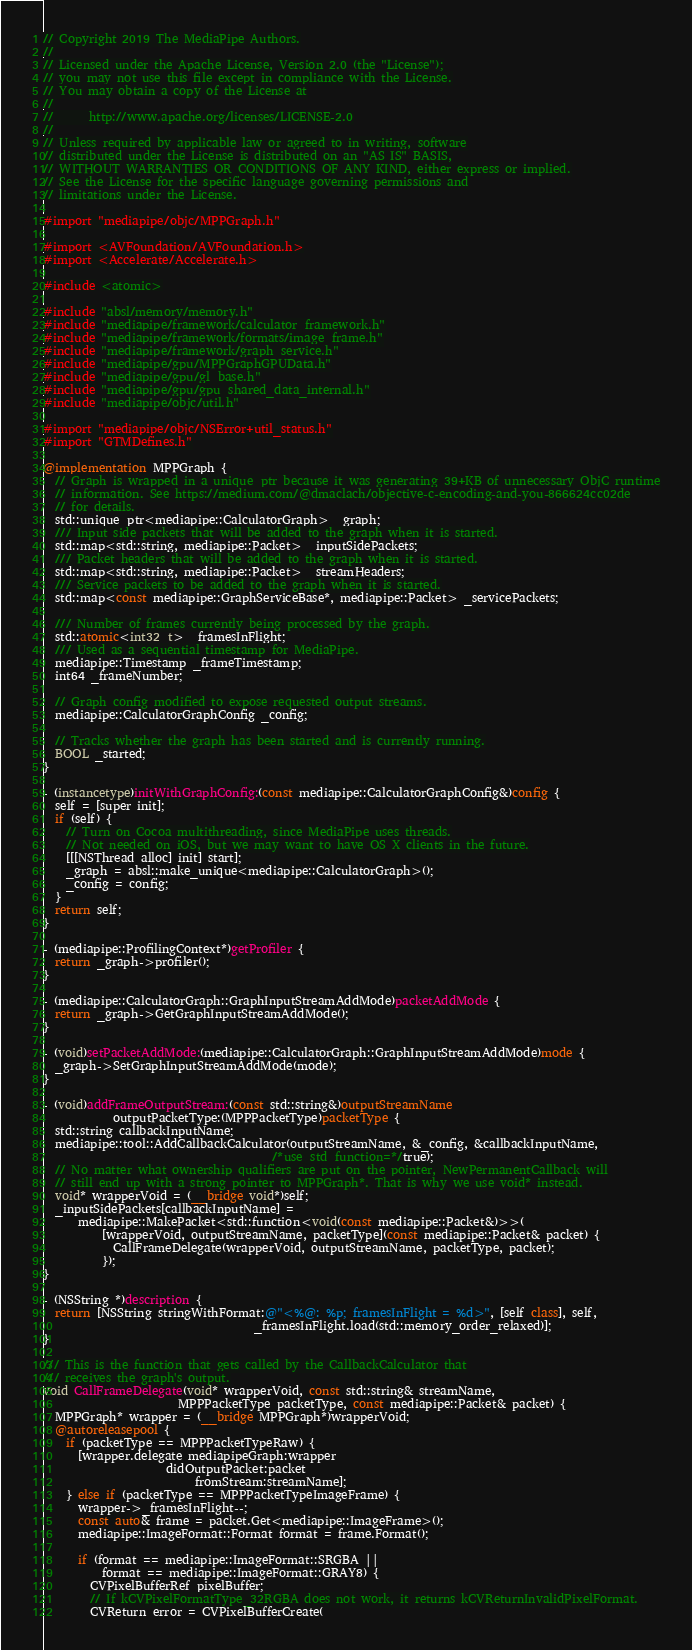<code> <loc_0><loc_0><loc_500><loc_500><_ObjectiveC_>// Copyright 2019 The MediaPipe Authors.
//
// Licensed under the Apache License, Version 2.0 (the "License");
// you may not use this file except in compliance with the License.
// You may obtain a copy of the License at
//
//      http://www.apache.org/licenses/LICENSE-2.0
//
// Unless required by applicable law or agreed to in writing, software
// distributed under the License is distributed on an "AS IS" BASIS,
// WITHOUT WARRANTIES OR CONDITIONS OF ANY KIND, either express or implied.
// See the License for the specific language governing permissions and
// limitations under the License.

#import "mediapipe/objc/MPPGraph.h"

#import <AVFoundation/AVFoundation.h>
#import <Accelerate/Accelerate.h>

#include <atomic>

#include "absl/memory/memory.h"
#include "mediapipe/framework/calculator_framework.h"
#include "mediapipe/framework/formats/image_frame.h"
#include "mediapipe/framework/graph_service.h"
#include "mediapipe/gpu/MPPGraphGPUData.h"
#include "mediapipe/gpu/gl_base.h"
#include "mediapipe/gpu/gpu_shared_data_internal.h"
#include "mediapipe/objc/util.h"

#import "mediapipe/objc/NSError+util_status.h"
#import "GTMDefines.h"

@implementation MPPGraph {
  // Graph is wrapped in a unique_ptr because it was generating 39+KB of unnecessary ObjC runtime
  // information. See https://medium.com/@dmaclach/objective-c-encoding-and-you-866624cc02de
  // for details.
  std::unique_ptr<mediapipe::CalculatorGraph> _graph;
  /// Input side packets that will be added to the graph when it is started.
  std::map<std::string, mediapipe::Packet> _inputSidePackets;
  /// Packet headers that will be added to the graph when it is started.
  std::map<std::string, mediapipe::Packet> _streamHeaders;
  /// Service packets to be added to the graph when it is started.
  std::map<const mediapipe::GraphServiceBase*, mediapipe::Packet> _servicePackets;

  /// Number of frames currently being processed by the graph.
  std::atomic<int32_t> _framesInFlight;
  /// Used as a sequential timestamp for MediaPipe.
  mediapipe::Timestamp _frameTimestamp;
  int64 _frameNumber;

  // Graph config modified to expose requested output streams.
  mediapipe::CalculatorGraphConfig _config;

  // Tracks whether the graph has been started and is currently running.
  BOOL _started;
}

- (instancetype)initWithGraphConfig:(const mediapipe::CalculatorGraphConfig&)config {
  self = [super init];
  if (self) {
    // Turn on Cocoa multithreading, since MediaPipe uses threads.
    // Not needed on iOS, but we may want to have OS X clients in the future.
    [[[NSThread alloc] init] start];
    _graph = absl::make_unique<mediapipe::CalculatorGraph>();
    _config = config;
  }
  return self;
}

- (mediapipe::ProfilingContext*)getProfiler {
  return _graph->profiler();
}

- (mediapipe::CalculatorGraph::GraphInputStreamAddMode)packetAddMode {
  return _graph->GetGraphInputStreamAddMode();
}

- (void)setPacketAddMode:(mediapipe::CalculatorGraph::GraphInputStreamAddMode)mode {
  _graph->SetGraphInputStreamAddMode(mode);
}

- (void)addFrameOutputStream:(const std::string&)outputStreamName
            outputPacketType:(MPPPacketType)packetType {
  std::string callbackInputName;
  mediapipe::tool::AddCallbackCalculator(outputStreamName, &_config, &callbackInputName,
                                       /*use_std_function=*/true);
  // No matter what ownership qualifiers are put on the pointer, NewPermanentCallback will
  // still end up with a strong pointer to MPPGraph*. That is why we use void* instead.
  void* wrapperVoid = (__bridge void*)self;
  _inputSidePackets[callbackInputName] =
      mediapipe::MakePacket<std::function<void(const mediapipe::Packet&)>>(
          [wrapperVoid, outputStreamName, packetType](const mediapipe::Packet& packet) {
            CallFrameDelegate(wrapperVoid, outputStreamName, packetType, packet);
          });
}

- (NSString *)description {
  return [NSString stringWithFormat:@"<%@: %p; framesInFlight = %d>", [self class], self,
                                    _framesInFlight.load(std::memory_order_relaxed)];
}

/// This is the function that gets called by the CallbackCalculator that
/// receives the graph's output.
void CallFrameDelegate(void* wrapperVoid, const std::string& streamName,
                       MPPPacketType packetType, const mediapipe::Packet& packet) {
  MPPGraph* wrapper = (__bridge MPPGraph*)wrapperVoid;
  @autoreleasepool {
    if (packetType == MPPPacketTypeRaw) {
      [wrapper.delegate mediapipeGraph:wrapper
                     didOutputPacket:packet
                          fromStream:streamName];
    } else if (packetType == MPPPacketTypeImageFrame) {
      wrapper->_framesInFlight--;
      const auto& frame = packet.Get<mediapipe::ImageFrame>();
      mediapipe::ImageFormat::Format format = frame.Format();

      if (format == mediapipe::ImageFormat::SRGBA ||
          format == mediapipe::ImageFormat::GRAY8) {
        CVPixelBufferRef pixelBuffer;
        // If kCVPixelFormatType_32RGBA does not work, it returns kCVReturnInvalidPixelFormat.
        CVReturn error = CVPixelBufferCreate(</code> 